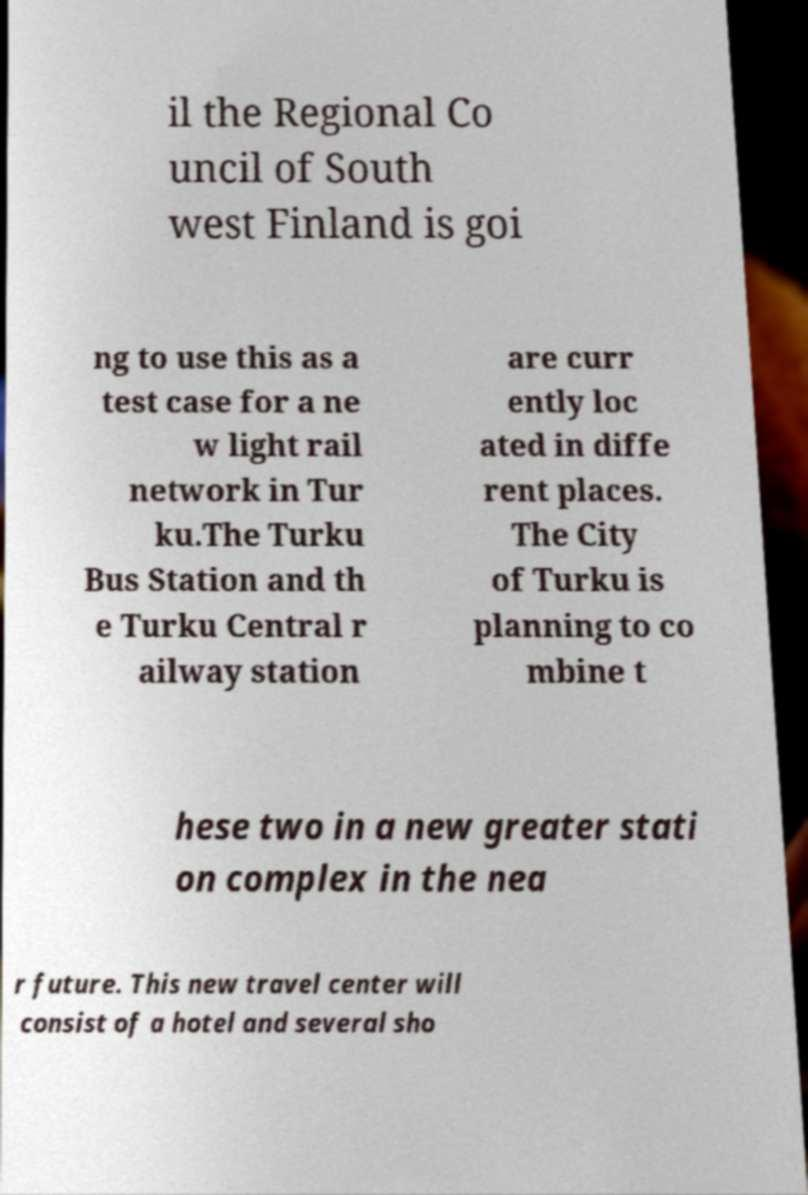Please identify and transcribe the text found in this image. il the Regional Co uncil of South west Finland is goi ng to use this as a test case for a ne w light rail network in Tur ku.The Turku Bus Station and th e Turku Central r ailway station are curr ently loc ated in diffe rent places. The City of Turku is planning to co mbine t hese two in a new greater stati on complex in the nea r future. This new travel center will consist of a hotel and several sho 